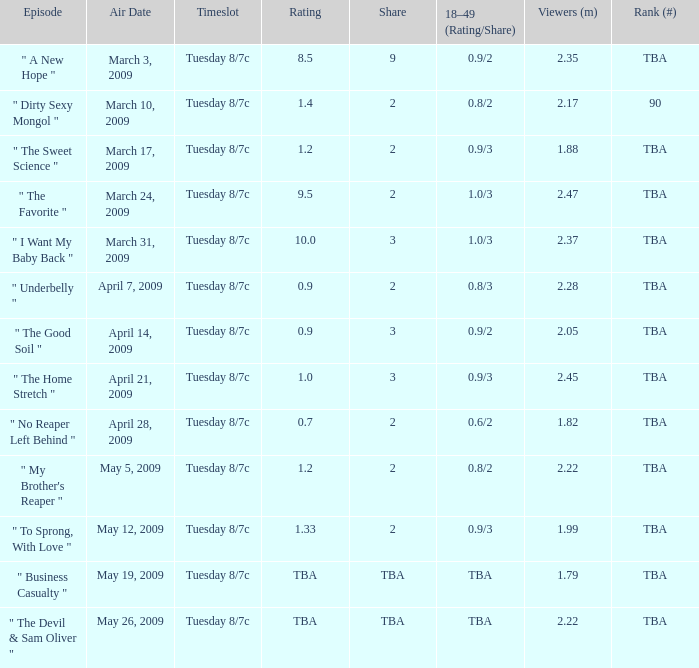What is the rank for the show aired on May 19, 2009? TBA. 